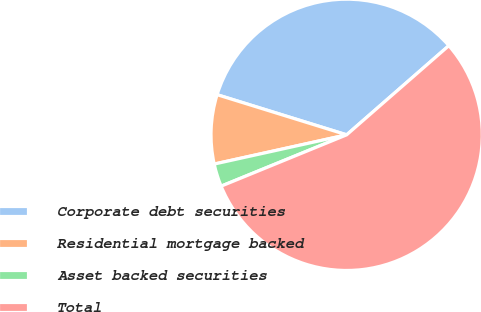Convert chart. <chart><loc_0><loc_0><loc_500><loc_500><pie_chart><fcel>Corporate debt securities<fcel>Residential mortgage backed<fcel>Asset backed securities<fcel>Total<nl><fcel>33.8%<fcel>8.24%<fcel>2.72%<fcel>55.24%<nl></chart> 